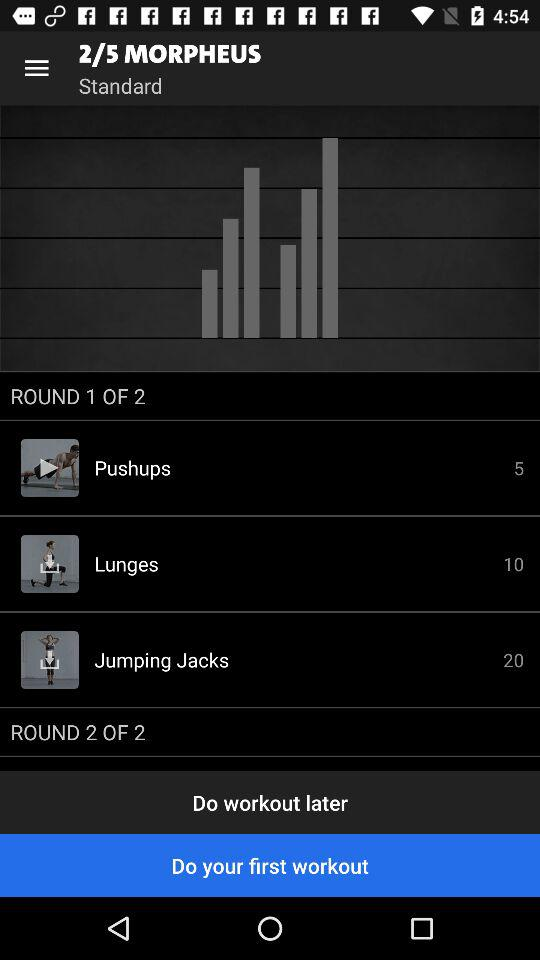How many pushups are there to do? There are 5 pushups to do. 